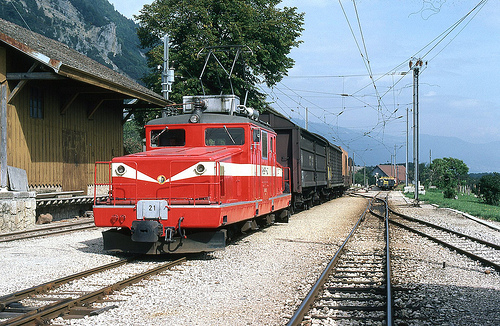Can you tell the time of day from the image? It appears to be midday or early afternoon, given the bright sunlight and the absence of long shadows. 